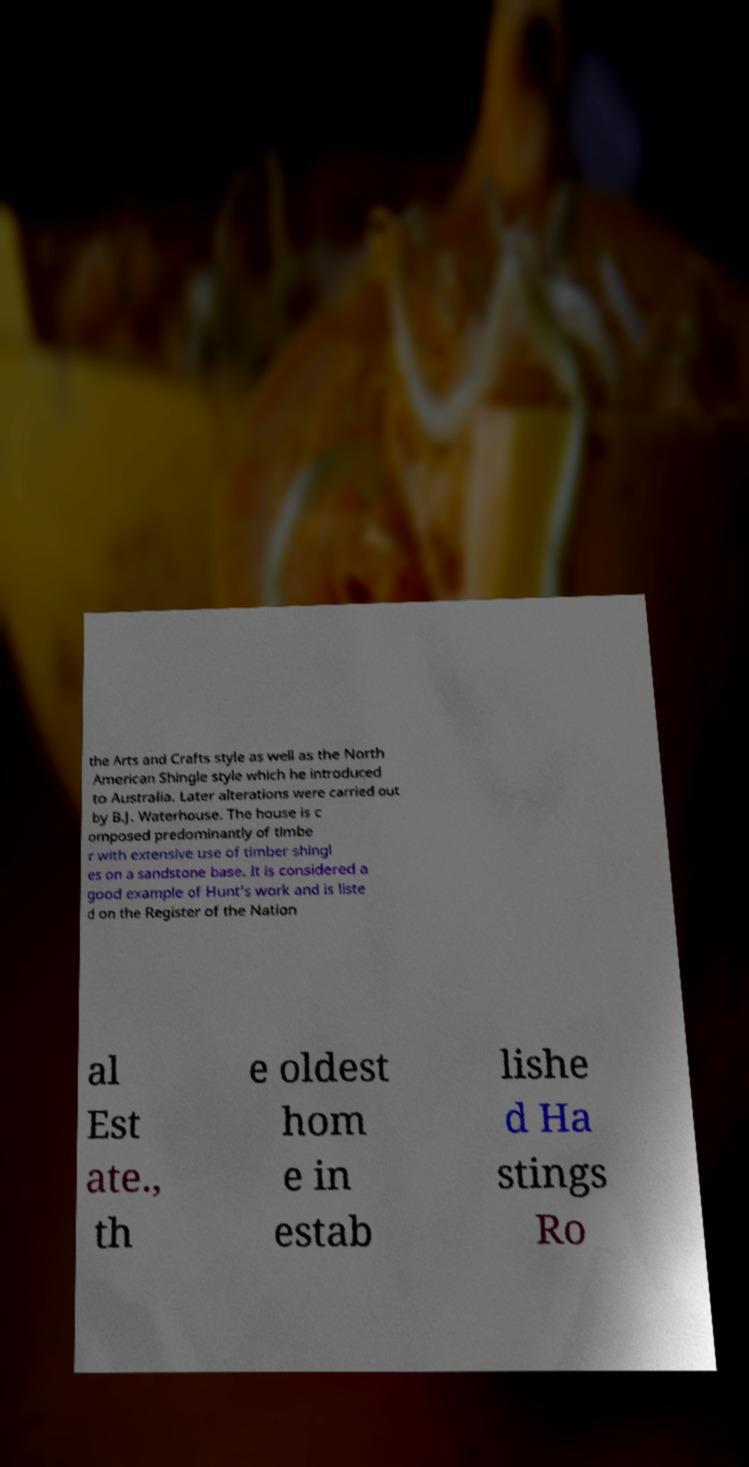Could you assist in decoding the text presented in this image and type it out clearly? the Arts and Crafts style as well as the North American Shingle style which he introduced to Australia. Later alterations were carried out by B.J. Waterhouse. The house is c omposed predominantly of timbe r with extensive use of timber shingl es on a sandstone base. It is considered a good example of Hunt's work and is liste d on the Register of the Nation al Est ate., th e oldest hom e in estab lishe d Ha stings Ro 